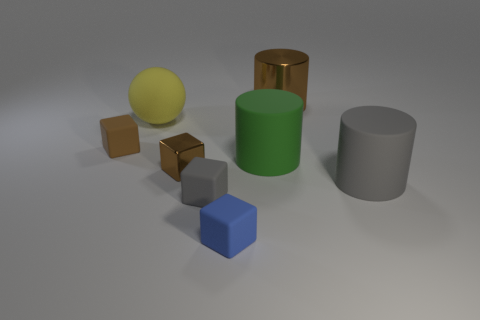Subtract 1 cylinders. How many cylinders are left? 2 Add 1 tiny objects. How many objects exist? 9 Subtract all cylinders. How many objects are left? 5 Subtract 0 yellow cylinders. How many objects are left? 8 Subtract all small cyan matte things. Subtract all gray rubber cubes. How many objects are left? 7 Add 7 brown blocks. How many brown blocks are left? 9 Add 6 red matte blocks. How many red matte blocks exist? 6 